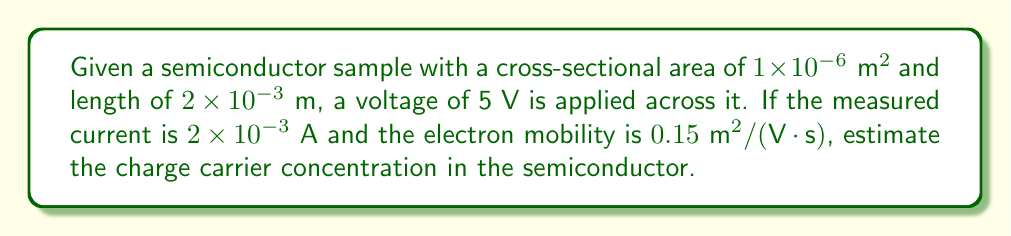Give your solution to this math problem. Let's approach this step-by-step:

1) First, we need to calculate the resistivity $\rho$ of the semiconductor using Ohm's law:

   $$R = \frac{V}{I} = \frac{\rho L}{A}$$

   where $R$ is resistance, $V$ is voltage, $I$ is current, $L$ is length, and $A$ is cross-sectional area.

2) Rearranging for $\rho$:

   $$\rho = \frac{VA}{IL}$$

3) Substituting the given values:

   $$\rho = \frac{5 \text{ V} \times 1 \times 10^{-6} \text{ m}^2}{2 \times 10^{-3} \text{ A} \times 2 \times 10^{-3} \text{ m}} = 1.25 \text{ }\Omega\cdot\text{m}$$

4) Now, we can use the relation between resistivity and charge carrier concentration:

   $$\rho = \frac{1}{ne\mu}$$

   where $n$ is the charge carrier concentration, $e$ is the elementary charge ($1.6 \times 10^{-19} \text{ C}$), and $\mu$ is the electron mobility.

5) Rearranging for $n$:

   $$n = \frac{1}{\rho e \mu}$$

6) Substituting the values:

   $$n = \frac{1}{1.25 \text{ }\Omega\cdot\text{m} \times 1.6 \times 10^{-19} \text{ C} \times 0.15 \text{ m}^2/(\text{V}\cdot\text{s})}$$

7) Calculating:

   $$n \approx 3.33 \times 10^{19} \text{ m}^{-3}$$
Answer: $3.33 \times 10^{19} \text{ m}^{-3}$ 